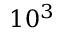Convert formula to latex. <formula><loc_0><loc_0><loc_500><loc_500>1 0 ^ { 3 }</formula> 